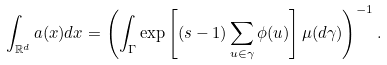<formula> <loc_0><loc_0><loc_500><loc_500>\int _ { \mathbb { R } ^ { d } } a ( x ) d x = \left ( \int _ { \Gamma } \exp \left [ ( s - 1 ) \sum _ { u \in \gamma } \phi ( u ) \right ] \mu ( d \gamma ) \right ) ^ { - 1 } .</formula> 